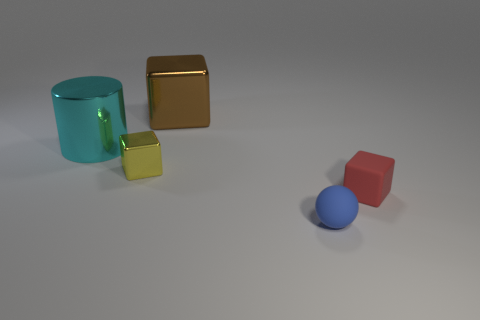What number of shiny things are in front of the tiny matte object that is behind the blue sphere?
Offer a terse response. 0. There is a yellow object that is the same shape as the large brown thing; what is its material?
Give a very brief answer. Metal. The rubber cube is what color?
Your answer should be compact. Red. How many things are either small brown shiny cylinders or small matte blocks?
Give a very brief answer. 1. There is a tiny thing that is in front of the small cube that is on the right side of the blue matte object; what shape is it?
Offer a very short reply. Sphere. What number of other things are there of the same material as the small yellow object
Make the answer very short. 2. Are the yellow object and the big object that is on the left side of the yellow metal block made of the same material?
Give a very brief answer. Yes. How many objects are either small rubber objects that are behind the blue object or small cubes right of the tiny rubber sphere?
Give a very brief answer. 1. What number of other things are there of the same color as the tiny metal cube?
Your response must be concise. 0. Is the number of tiny yellow objects that are behind the big cyan metal thing greater than the number of cyan shiny cylinders that are in front of the large brown shiny object?
Provide a short and direct response. No. 